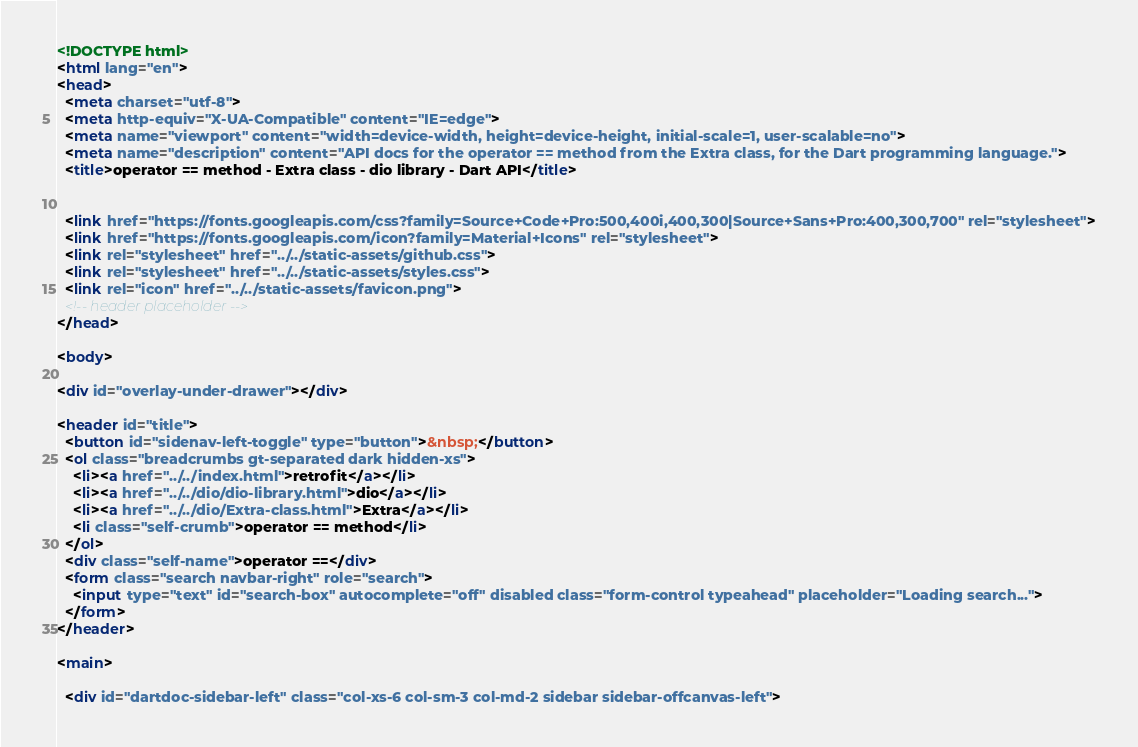Convert code to text. <code><loc_0><loc_0><loc_500><loc_500><_HTML_><!DOCTYPE html>
<html lang="en">
<head>
  <meta charset="utf-8">
  <meta http-equiv="X-UA-Compatible" content="IE=edge">
  <meta name="viewport" content="width=device-width, height=device-height, initial-scale=1, user-scalable=no">
  <meta name="description" content="API docs for the operator == method from the Extra class, for the Dart programming language.">
  <title>operator == method - Extra class - dio library - Dart API</title>

  
  <link href="https://fonts.googleapis.com/css?family=Source+Code+Pro:500,400i,400,300|Source+Sans+Pro:400,300,700" rel="stylesheet">
  <link href="https://fonts.googleapis.com/icon?family=Material+Icons" rel="stylesheet">
  <link rel="stylesheet" href="../../static-assets/github.css">
  <link rel="stylesheet" href="../../static-assets/styles.css">
  <link rel="icon" href="../../static-assets/favicon.png">
  <!-- header placeholder -->
</head>

<body>

<div id="overlay-under-drawer"></div>

<header id="title">
  <button id="sidenav-left-toggle" type="button">&nbsp;</button>
  <ol class="breadcrumbs gt-separated dark hidden-xs">
    <li><a href="../../index.html">retrofit</a></li>
    <li><a href="../../dio/dio-library.html">dio</a></li>
    <li><a href="../../dio/Extra-class.html">Extra</a></li>
    <li class="self-crumb">operator == method</li>
  </ol>
  <div class="self-name">operator ==</div>
  <form class="search navbar-right" role="search">
    <input type="text" id="search-box" autocomplete="off" disabled class="form-control typeahead" placeholder="Loading search...">
  </form>
</header>

<main>

  <div id="dartdoc-sidebar-left" class="col-xs-6 col-sm-3 col-md-2 sidebar sidebar-offcanvas-left"></code> 